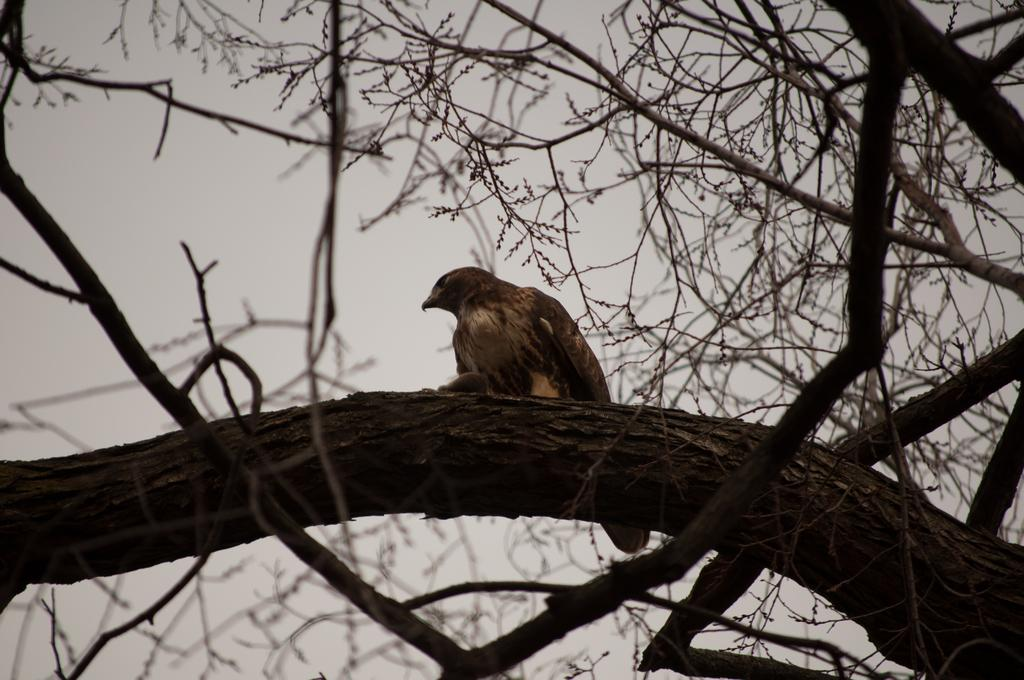What type of animal can be seen in the image? There is a bird in the image. Where is the bird located in the image? The bird is sitting on a tree branch. What is the color of the sky in the image? The sky is pale gray in color. What is the bird's opinion on the current profit margins in the image? There is no indication of the bird's opinion on profit margins in the image, as birds do not have the ability to express opinions or understand financial concepts. 